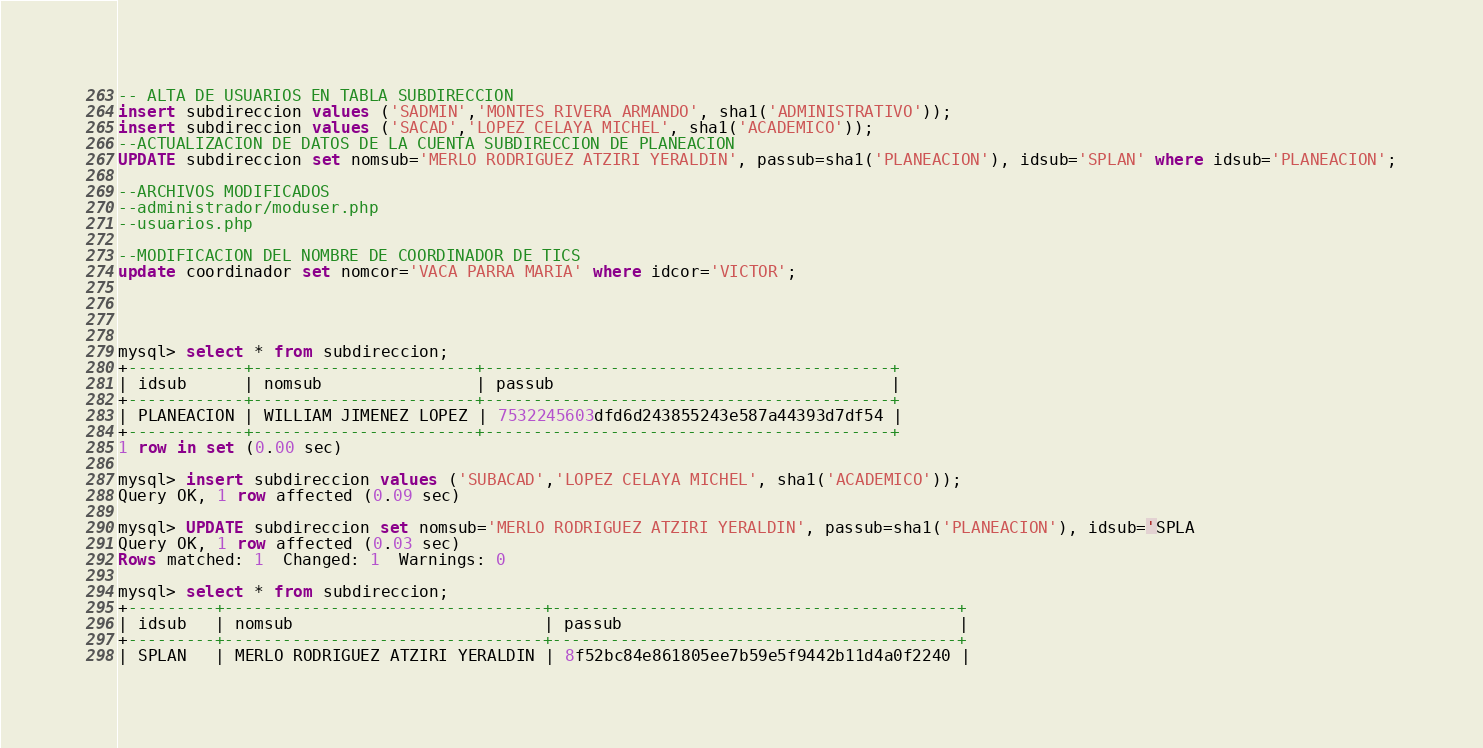<code> <loc_0><loc_0><loc_500><loc_500><_SQL_>-- ALTA DE USUARIOS EN TABLA SUBDIRECCION
insert subdireccion values ('SADMIN','MONTES RIVERA ARMANDO', sha1('ADMINISTRATIVO'));
insert subdireccion values ('SACAD','LOPEZ CELAYA MICHEL', sha1('ACADEMICO'));
--ACTUALIZACION DE DATOS DE LA CUENTA SUBDIRECCION DE PLANEACION
UPDATE subdireccion set nomsub='MERLO RODRIGUEZ ATZIRI YERALDIN', passub=sha1('PLANEACION'), idsub='SPLAN' where idsub='PLANEACION';

--ARCHIVOS MODIFICADOS
--administrador/moduser.php
--usuarios.php

--MODIFICACION DEL NOMBRE DE COORDINADOR DE TICS
update coordinador set nomcor='VACA PARRA MARIA' where idcor='VICTOR';




mysql> select * from subdireccion;
+------------+-----------------------+------------------------------------------+
| idsub      | nomsub                | passub                                   |
+------------+-----------------------+------------------------------------------+
| PLANEACION | WILLIAM JIMENEZ LOPEZ | 7532245603dfd6d243855243e587a44393d7df54 |
+------------+-----------------------+------------------------------------------+
1 row in set (0.00 sec)

mysql> insert subdireccion values ('SUBACAD','LOPEZ CELAYA MICHEL', sha1('ACADEMICO'));
Query OK, 1 row affected (0.09 sec)

mysql> UPDATE subdireccion set nomsub='MERLO RODRIGUEZ ATZIRI YERALDIN', passub=sha1('PLANEACION'), idsub='SPLA
Query OK, 1 row affected (0.03 sec)
Rows matched: 1  Changed: 1  Warnings: 0

mysql> select * from subdireccion;
+---------+---------------------------------+------------------------------------------+
| idsub   | nomsub                          | passub                                   |
+---------+---------------------------------+------------------------------------------+
| SPLAN   | MERLO RODRIGUEZ ATZIRI YERALDIN | 8f52bc84e861805ee7b59e5f9442b11d4a0f2240 |</code> 